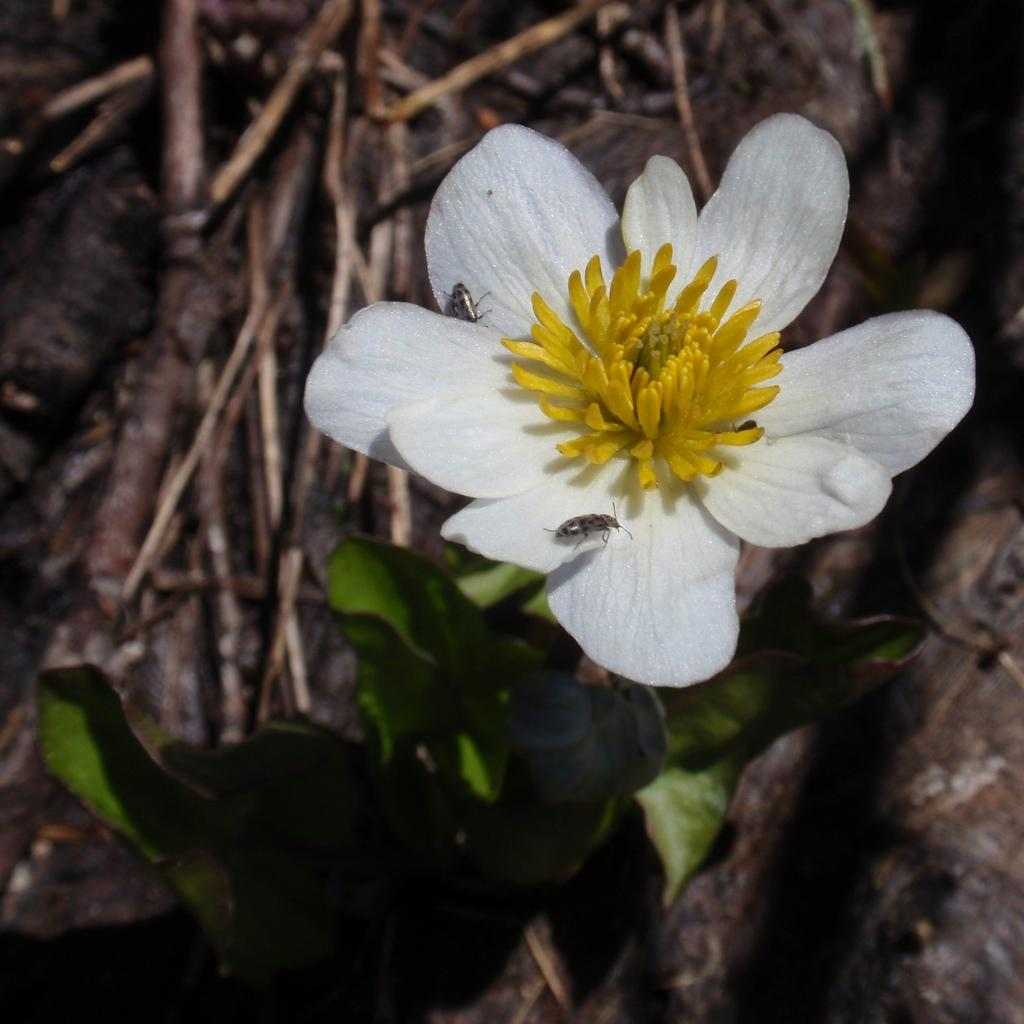What is the main subject of the image? There is a flower in the image. What can be seen on the flower? Insects are present on the flower. What is located below the flower? There are leaves below the flower. How would you describe the background of the image? The background of the image is blurred. What else can be seen in the background? There are sticks visible in the background. What type of paste is being used by the insects on the flower in the image? There is no paste present in the image; the insects are simply on the flower. 